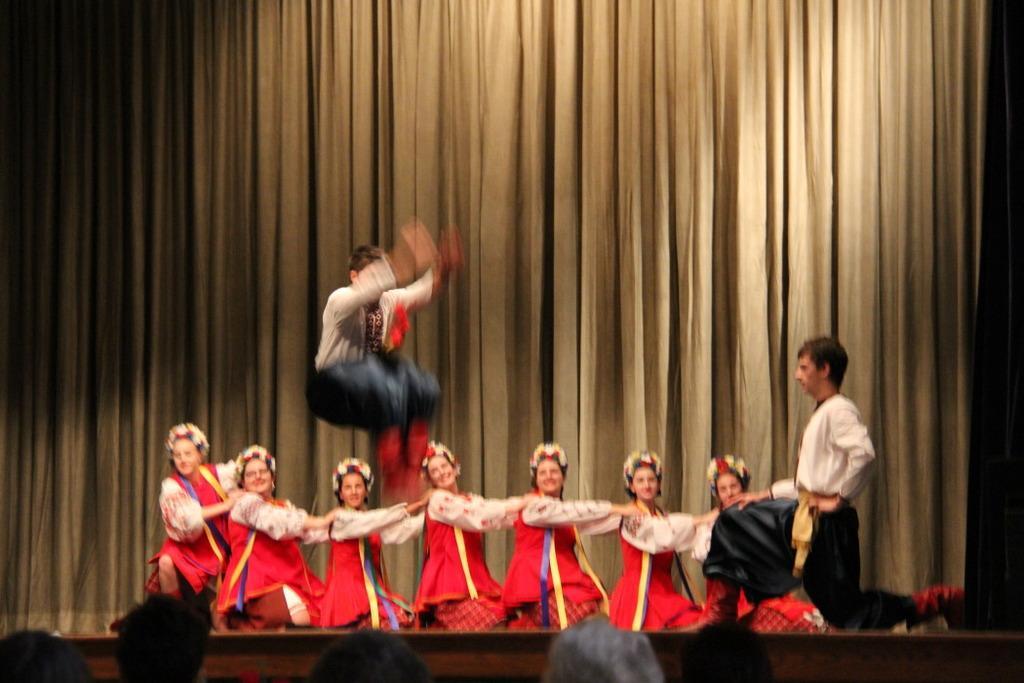Can you describe this image briefly? In this image we can see people wearing costumes and performing and there is a man jumping. At the bottom we can see people. In the background there is a curtain. 